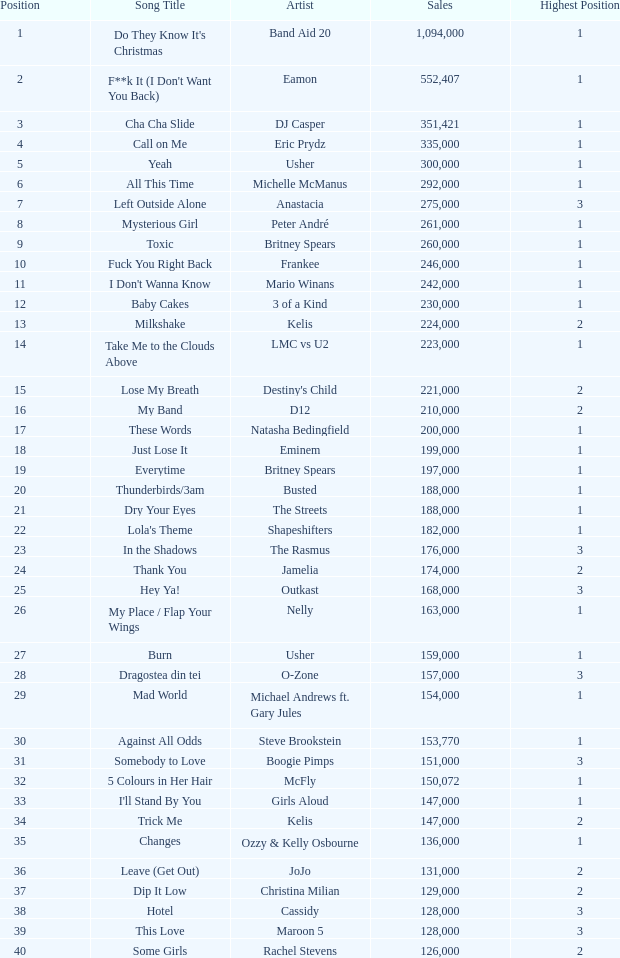What were the proceeds for dj casper when his position was under 13? 351421.0. 